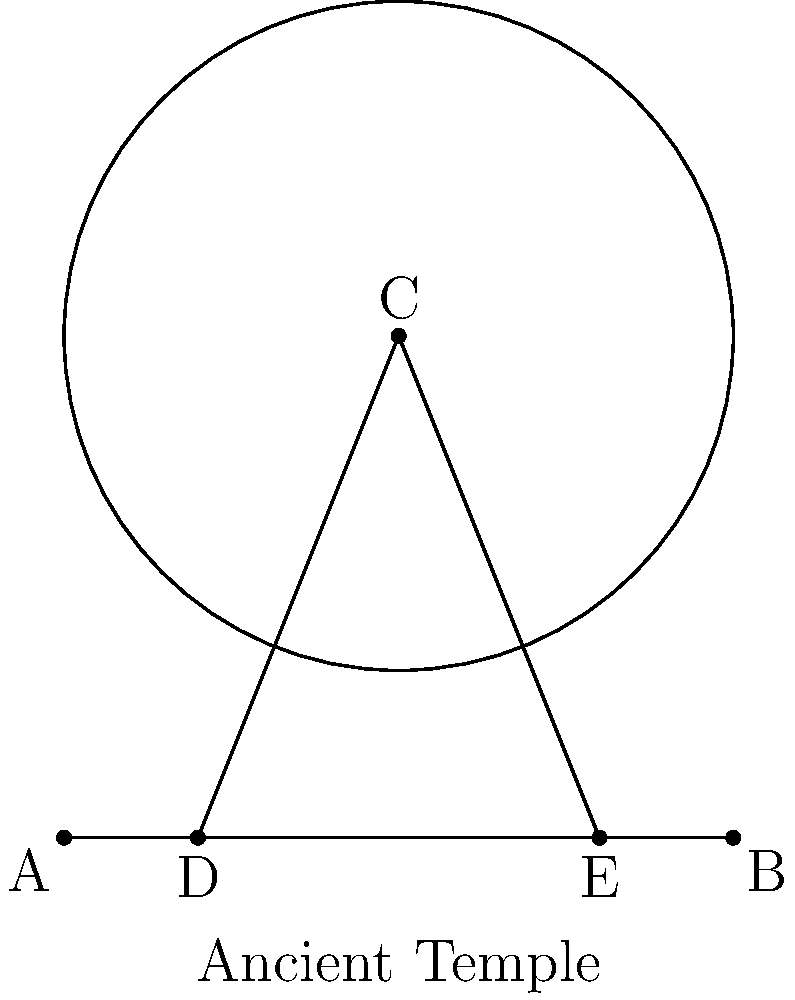In an archaeological study of an ancient Greek temple, researchers discovered a circular dome with a diameter of 40 meters. A straight line from the center of the dome to the ground forms a right angle with the ground. If a tangent line is drawn from point A on the ground to the edge of the dome, and a secant line is drawn from the same point through the dome, intersecting it at points D and E, such that AD = 8 meters and AE = 32 meters, what is the height of the dome in meters? Let's approach this step-by-step using the tangent-secant theorem and the Pythagorean theorem:

1) First, recall the tangent-secant theorem: If a tangent and a secant are drawn to a circle from an external point, then the square of the length of the tangent equals the product of the whole secant and its external part.

2) In this case, let AC be the tangent and AE be the secant. Let's call the length of AC as x. Then:

   $x^2 = AE \cdot AD = 32 \cdot 8 = 256$

3) Solving for x:
   $x = \sqrt{256} = 16$ meters

4) Now we know AC = 16 meters, which is the tangent to the circle from point A.

5) The radius of the dome is half the diameter, so r = 20 meters.

6) We can now use the Pythagorean theorem in the right triangle formed by the radius perpendicular to the ground, the tangent line, and half of the ground line:

   $r^2 = (\frac{AB}{2})^2 + h^2$

   Where h is the height of the dome and AB is the length of the ground line.

7) We can find AB using the Pythagorean theorem again:
   $AB^2 = AC^2 + BC^2$
   $AB^2 = 16^2 + 40^2 = 256 + 1600 = 1856$
   $AB = \sqrt{1856} \approx 43.08$ meters

8) Now we can solve for h:

   $20^2 = (\frac{43.08}{2})^2 + h^2$
   $400 = 464.6632 + h^2$
   $h^2 = 400 - 464.6632 = -64.6632$
   $h = \sqrt{64.6632} \approx 30$ meters

Therefore, the height of the dome is approximately 30 meters.
Answer: 30 meters 